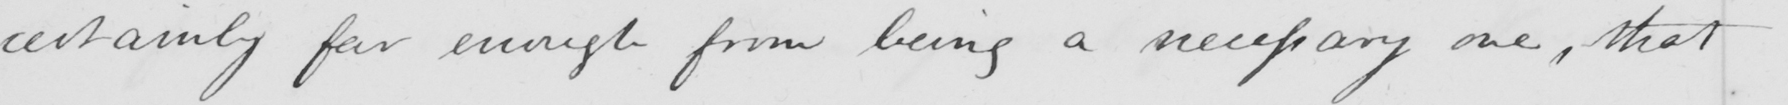Please transcribe the handwritten text in this image. certainly far enough from being a necessary one , that 